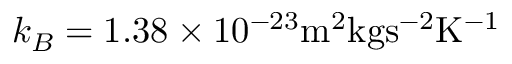Convert formula to latex. <formula><loc_0><loc_0><loc_500><loc_500>k _ { B } = 1 . 3 8 \times 1 0 ^ { - 2 3 } m ^ { 2 } k g s ^ { - 2 } K ^ { - 1 }</formula> 